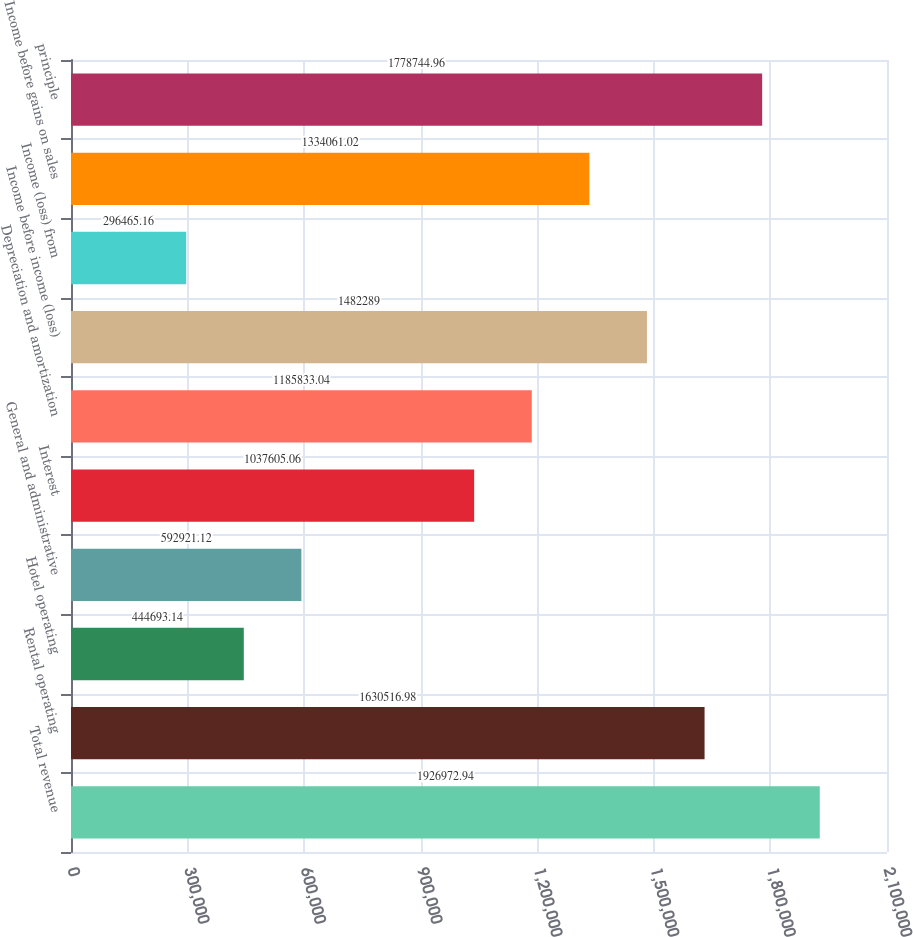<chart> <loc_0><loc_0><loc_500><loc_500><bar_chart><fcel>Total revenue<fcel>Rental operating<fcel>Hotel operating<fcel>General and administrative<fcel>Interest<fcel>Depreciation and amortization<fcel>Income before income (loss)<fcel>Income (loss) from<fcel>Income before gains on sales<fcel>principle<nl><fcel>1.92697e+06<fcel>1.63052e+06<fcel>444693<fcel>592921<fcel>1.03761e+06<fcel>1.18583e+06<fcel>1.48229e+06<fcel>296465<fcel>1.33406e+06<fcel>1.77874e+06<nl></chart> 